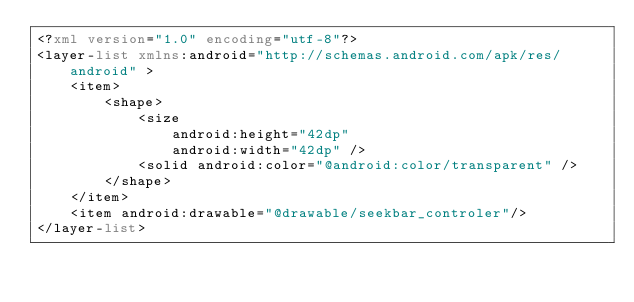Convert code to text. <code><loc_0><loc_0><loc_500><loc_500><_XML_><?xml version="1.0" encoding="utf-8"?>
<layer-list xmlns:android="http://schemas.android.com/apk/res/android" >
    <item>
        <shape>
            <size
                android:height="42dp"
                android:width="42dp" />
            <solid android:color="@android:color/transparent" />
        </shape>
    </item>
    <item android:drawable="@drawable/seekbar_controler"/>
</layer-list></code> 